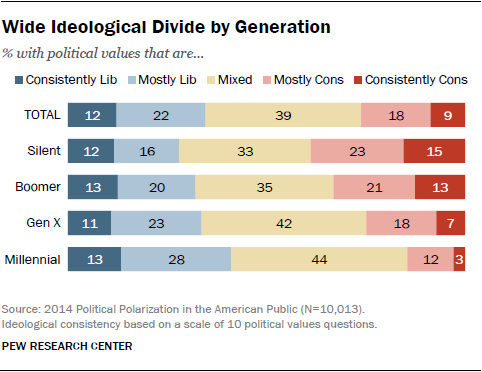Mention a couple of crucial points in this snapshot. This document includes four age groups. According to the survey, there are two age groups with over 10% of their members who consider themselves consistently conservative. 